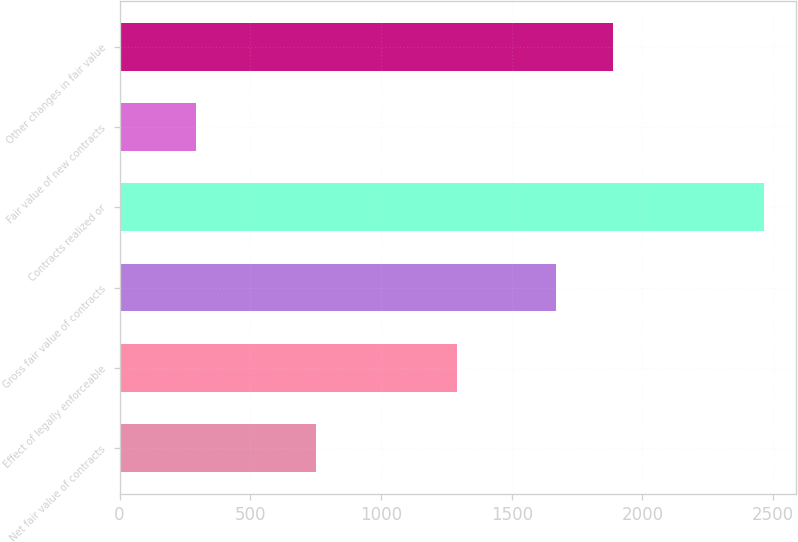Convert chart to OTSL. <chart><loc_0><loc_0><loc_500><loc_500><bar_chart><fcel>Net fair value of contracts<fcel>Effect of legally enforceable<fcel>Gross fair value of contracts<fcel>Contracts realized or<fcel>Fair value of new contracts<fcel>Other changes in fair value<nl><fcel>751<fcel>1289<fcel>1670<fcel>2465<fcel>291<fcel>1887.4<nl></chart> 